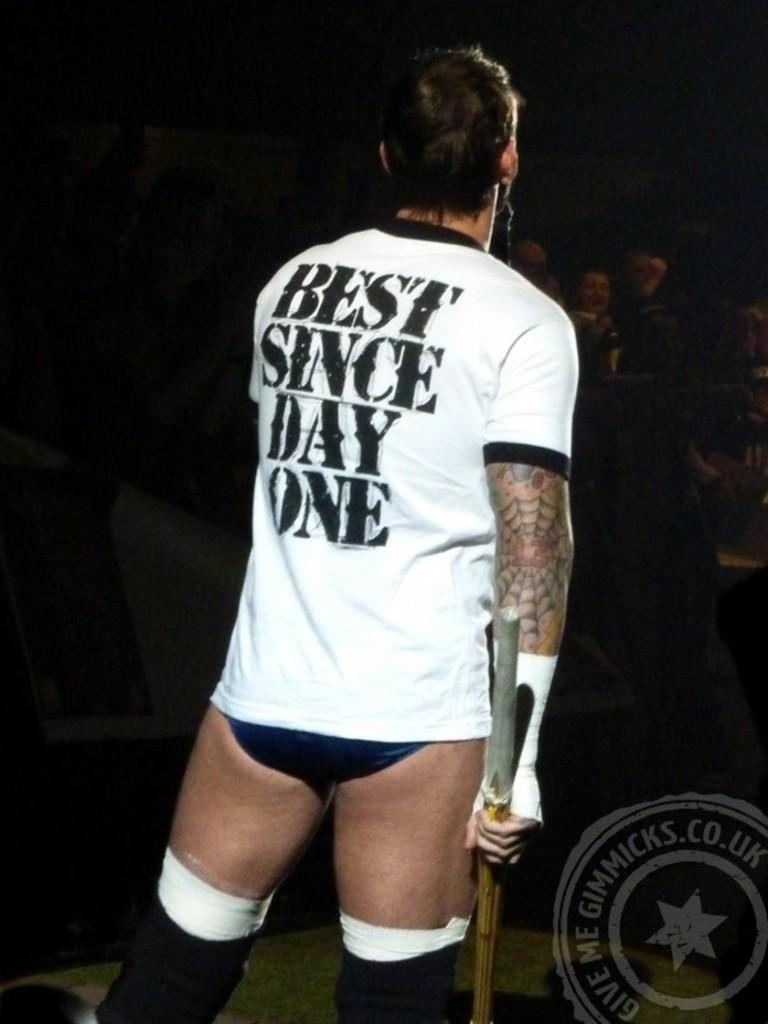Provide a one-sentence caption for the provided image. The man has a white shirt that says "Best Since Day One.". 